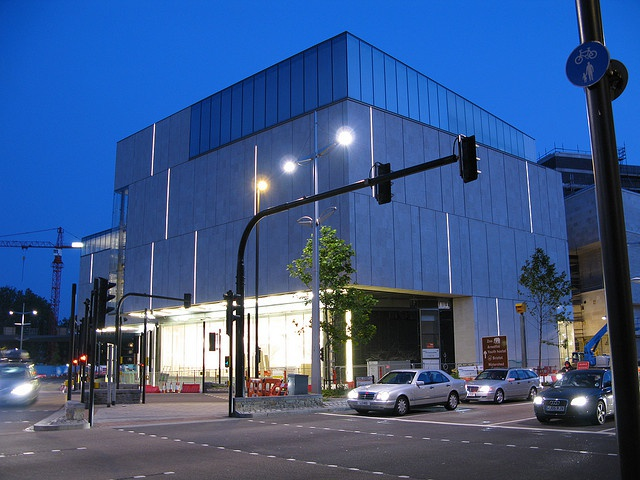Describe the objects in this image and their specific colors. I can see car in blue, black, gray, and lavender tones, car in blue, black, navy, gray, and darkblue tones, car in blue, gray, black, and navy tones, car in blue, gray, white, and darkgray tones, and traffic light in blue, black, navy, and darkblue tones in this image. 